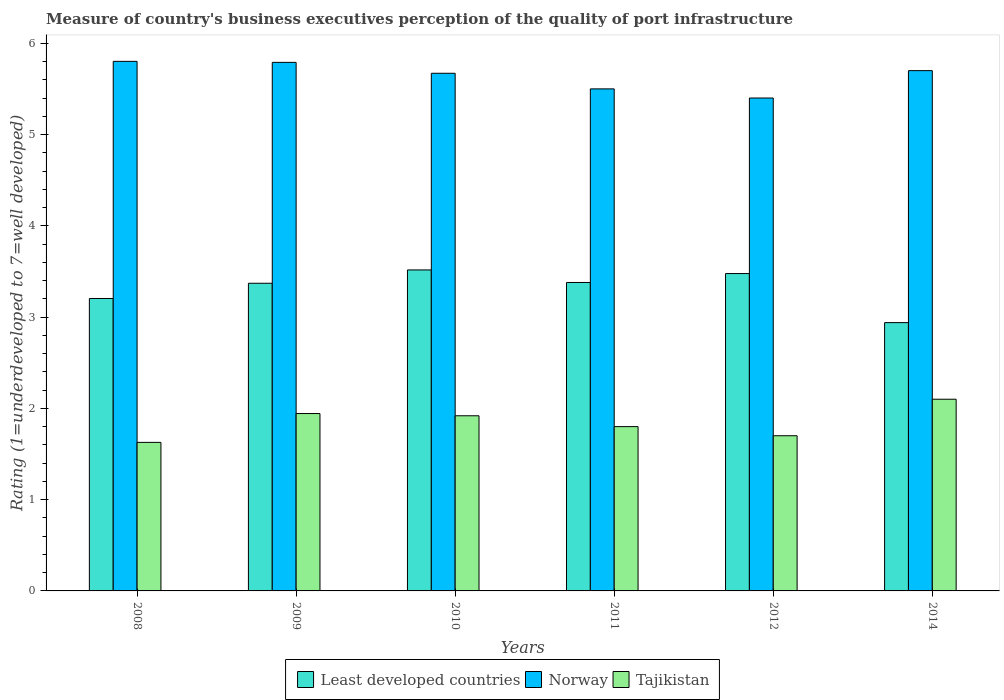Are the number of bars on each tick of the X-axis equal?
Your response must be concise. Yes. How many bars are there on the 2nd tick from the right?
Your response must be concise. 3. In how many cases, is the number of bars for a given year not equal to the number of legend labels?
Provide a succinct answer. 0. What is the ratings of the quality of port infrastructure in Least developed countries in 2010?
Provide a short and direct response. 3.52. Across all years, what is the maximum ratings of the quality of port infrastructure in Norway?
Offer a terse response. 5.8. Across all years, what is the minimum ratings of the quality of port infrastructure in Least developed countries?
Keep it short and to the point. 2.94. What is the total ratings of the quality of port infrastructure in Norway in the graph?
Offer a very short reply. 33.86. What is the difference between the ratings of the quality of port infrastructure in Least developed countries in 2008 and that in 2010?
Your answer should be compact. -0.31. What is the difference between the ratings of the quality of port infrastructure in Least developed countries in 2010 and the ratings of the quality of port infrastructure in Tajikistan in 2009?
Ensure brevity in your answer.  1.57. What is the average ratings of the quality of port infrastructure in Norway per year?
Offer a very short reply. 5.64. In the year 2012, what is the difference between the ratings of the quality of port infrastructure in Tajikistan and ratings of the quality of port infrastructure in Least developed countries?
Keep it short and to the point. -1.78. In how many years, is the ratings of the quality of port infrastructure in Norway greater than 2.4?
Make the answer very short. 6. What is the ratio of the ratings of the quality of port infrastructure in Least developed countries in 2011 to that in 2014?
Provide a short and direct response. 1.15. Is the ratings of the quality of port infrastructure in Least developed countries in 2009 less than that in 2014?
Provide a succinct answer. No. What is the difference between the highest and the second highest ratings of the quality of port infrastructure in Norway?
Offer a terse response. 0.01. What is the difference between the highest and the lowest ratings of the quality of port infrastructure in Norway?
Your answer should be compact. 0.4. What does the 2nd bar from the left in 2010 represents?
Ensure brevity in your answer.  Norway. What does the 2nd bar from the right in 2011 represents?
Provide a short and direct response. Norway. How many bars are there?
Keep it short and to the point. 18. How many years are there in the graph?
Your answer should be compact. 6. Does the graph contain any zero values?
Offer a very short reply. No. Does the graph contain grids?
Your response must be concise. No. Where does the legend appear in the graph?
Your answer should be very brief. Bottom center. How many legend labels are there?
Your answer should be compact. 3. What is the title of the graph?
Your response must be concise. Measure of country's business executives perception of the quality of port infrastructure. Does "Croatia" appear as one of the legend labels in the graph?
Offer a very short reply. No. What is the label or title of the Y-axis?
Your response must be concise. Rating (1=underdeveloped to 7=well developed). What is the Rating (1=underdeveloped to 7=well developed) in Least developed countries in 2008?
Offer a very short reply. 3.2. What is the Rating (1=underdeveloped to 7=well developed) of Norway in 2008?
Give a very brief answer. 5.8. What is the Rating (1=underdeveloped to 7=well developed) of Tajikistan in 2008?
Your response must be concise. 1.63. What is the Rating (1=underdeveloped to 7=well developed) in Least developed countries in 2009?
Give a very brief answer. 3.37. What is the Rating (1=underdeveloped to 7=well developed) of Norway in 2009?
Offer a very short reply. 5.79. What is the Rating (1=underdeveloped to 7=well developed) in Tajikistan in 2009?
Offer a very short reply. 1.94. What is the Rating (1=underdeveloped to 7=well developed) of Least developed countries in 2010?
Offer a very short reply. 3.52. What is the Rating (1=underdeveloped to 7=well developed) of Norway in 2010?
Give a very brief answer. 5.67. What is the Rating (1=underdeveloped to 7=well developed) of Tajikistan in 2010?
Offer a terse response. 1.92. What is the Rating (1=underdeveloped to 7=well developed) in Least developed countries in 2011?
Ensure brevity in your answer.  3.38. What is the Rating (1=underdeveloped to 7=well developed) in Least developed countries in 2012?
Keep it short and to the point. 3.48. What is the Rating (1=underdeveloped to 7=well developed) in Tajikistan in 2012?
Your answer should be very brief. 1.7. What is the Rating (1=underdeveloped to 7=well developed) in Least developed countries in 2014?
Your answer should be compact. 2.94. What is the Rating (1=underdeveloped to 7=well developed) of Norway in 2014?
Offer a terse response. 5.7. What is the Rating (1=underdeveloped to 7=well developed) of Tajikistan in 2014?
Offer a terse response. 2.1. Across all years, what is the maximum Rating (1=underdeveloped to 7=well developed) in Least developed countries?
Make the answer very short. 3.52. Across all years, what is the maximum Rating (1=underdeveloped to 7=well developed) in Norway?
Your answer should be very brief. 5.8. Across all years, what is the maximum Rating (1=underdeveloped to 7=well developed) of Tajikistan?
Your answer should be compact. 2.1. Across all years, what is the minimum Rating (1=underdeveloped to 7=well developed) in Least developed countries?
Provide a short and direct response. 2.94. Across all years, what is the minimum Rating (1=underdeveloped to 7=well developed) of Tajikistan?
Provide a short and direct response. 1.63. What is the total Rating (1=underdeveloped to 7=well developed) of Least developed countries in the graph?
Offer a very short reply. 19.89. What is the total Rating (1=underdeveloped to 7=well developed) of Norway in the graph?
Your response must be concise. 33.86. What is the total Rating (1=underdeveloped to 7=well developed) in Tajikistan in the graph?
Your response must be concise. 11.09. What is the difference between the Rating (1=underdeveloped to 7=well developed) in Least developed countries in 2008 and that in 2009?
Ensure brevity in your answer.  -0.17. What is the difference between the Rating (1=underdeveloped to 7=well developed) in Norway in 2008 and that in 2009?
Provide a short and direct response. 0.01. What is the difference between the Rating (1=underdeveloped to 7=well developed) of Tajikistan in 2008 and that in 2009?
Offer a terse response. -0.32. What is the difference between the Rating (1=underdeveloped to 7=well developed) of Least developed countries in 2008 and that in 2010?
Keep it short and to the point. -0.31. What is the difference between the Rating (1=underdeveloped to 7=well developed) of Norway in 2008 and that in 2010?
Keep it short and to the point. 0.13. What is the difference between the Rating (1=underdeveloped to 7=well developed) in Tajikistan in 2008 and that in 2010?
Your answer should be very brief. -0.29. What is the difference between the Rating (1=underdeveloped to 7=well developed) of Least developed countries in 2008 and that in 2011?
Your answer should be very brief. -0.18. What is the difference between the Rating (1=underdeveloped to 7=well developed) of Norway in 2008 and that in 2011?
Offer a terse response. 0.3. What is the difference between the Rating (1=underdeveloped to 7=well developed) in Tajikistan in 2008 and that in 2011?
Your response must be concise. -0.17. What is the difference between the Rating (1=underdeveloped to 7=well developed) in Least developed countries in 2008 and that in 2012?
Your response must be concise. -0.27. What is the difference between the Rating (1=underdeveloped to 7=well developed) in Norway in 2008 and that in 2012?
Your answer should be compact. 0.4. What is the difference between the Rating (1=underdeveloped to 7=well developed) of Tajikistan in 2008 and that in 2012?
Ensure brevity in your answer.  -0.07. What is the difference between the Rating (1=underdeveloped to 7=well developed) in Least developed countries in 2008 and that in 2014?
Provide a short and direct response. 0.26. What is the difference between the Rating (1=underdeveloped to 7=well developed) of Norway in 2008 and that in 2014?
Provide a short and direct response. 0.1. What is the difference between the Rating (1=underdeveloped to 7=well developed) of Tajikistan in 2008 and that in 2014?
Offer a terse response. -0.47. What is the difference between the Rating (1=underdeveloped to 7=well developed) of Least developed countries in 2009 and that in 2010?
Your answer should be very brief. -0.15. What is the difference between the Rating (1=underdeveloped to 7=well developed) of Norway in 2009 and that in 2010?
Your answer should be very brief. 0.12. What is the difference between the Rating (1=underdeveloped to 7=well developed) of Tajikistan in 2009 and that in 2010?
Provide a succinct answer. 0.02. What is the difference between the Rating (1=underdeveloped to 7=well developed) of Least developed countries in 2009 and that in 2011?
Give a very brief answer. -0.01. What is the difference between the Rating (1=underdeveloped to 7=well developed) of Norway in 2009 and that in 2011?
Your response must be concise. 0.29. What is the difference between the Rating (1=underdeveloped to 7=well developed) of Tajikistan in 2009 and that in 2011?
Make the answer very short. 0.14. What is the difference between the Rating (1=underdeveloped to 7=well developed) of Least developed countries in 2009 and that in 2012?
Offer a terse response. -0.11. What is the difference between the Rating (1=underdeveloped to 7=well developed) in Norway in 2009 and that in 2012?
Your answer should be very brief. 0.39. What is the difference between the Rating (1=underdeveloped to 7=well developed) in Tajikistan in 2009 and that in 2012?
Keep it short and to the point. 0.24. What is the difference between the Rating (1=underdeveloped to 7=well developed) in Least developed countries in 2009 and that in 2014?
Your response must be concise. 0.43. What is the difference between the Rating (1=underdeveloped to 7=well developed) in Norway in 2009 and that in 2014?
Give a very brief answer. 0.09. What is the difference between the Rating (1=underdeveloped to 7=well developed) in Tajikistan in 2009 and that in 2014?
Your response must be concise. -0.16. What is the difference between the Rating (1=underdeveloped to 7=well developed) of Least developed countries in 2010 and that in 2011?
Ensure brevity in your answer.  0.14. What is the difference between the Rating (1=underdeveloped to 7=well developed) in Norway in 2010 and that in 2011?
Offer a very short reply. 0.17. What is the difference between the Rating (1=underdeveloped to 7=well developed) of Tajikistan in 2010 and that in 2011?
Provide a succinct answer. 0.12. What is the difference between the Rating (1=underdeveloped to 7=well developed) of Least developed countries in 2010 and that in 2012?
Your answer should be compact. 0.04. What is the difference between the Rating (1=underdeveloped to 7=well developed) in Norway in 2010 and that in 2012?
Ensure brevity in your answer.  0.27. What is the difference between the Rating (1=underdeveloped to 7=well developed) in Tajikistan in 2010 and that in 2012?
Provide a short and direct response. 0.22. What is the difference between the Rating (1=underdeveloped to 7=well developed) of Least developed countries in 2010 and that in 2014?
Provide a succinct answer. 0.58. What is the difference between the Rating (1=underdeveloped to 7=well developed) of Norway in 2010 and that in 2014?
Offer a very short reply. -0.03. What is the difference between the Rating (1=underdeveloped to 7=well developed) in Tajikistan in 2010 and that in 2014?
Ensure brevity in your answer.  -0.18. What is the difference between the Rating (1=underdeveloped to 7=well developed) of Least developed countries in 2011 and that in 2012?
Provide a short and direct response. -0.1. What is the difference between the Rating (1=underdeveloped to 7=well developed) of Norway in 2011 and that in 2012?
Offer a terse response. 0.1. What is the difference between the Rating (1=underdeveloped to 7=well developed) of Tajikistan in 2011 and that in 2012?
Keep it short and to the point. 0.1. What is the difference between the Rating (1=underdeveloped to 7=well developed) of Least developed countries in 2011 and that in 2014?
Make the answer very short. 0.44. What is the difference between the Rating (1=underdeveloped to 7=well developed) of Least developed countries in 2012 and that in 2014?
Your response must be concise. 0.54. What is the difference between the Rating (1=underdeveloped to 7=well developed) in Least developed countries in 2008 and the Rating (1=underdeveloped to 7=well developed) in Norway in 2009?
Offer a terse response. -2.59. What is the difference between the Rating (1=underdeveloped to 7=well developed) of Least developed countries in 2008 and the Rating (1=underdeveloped to 7=well developed) of Tajikistan in 2009?
Give a very brief answer. 1.26. What is the difference between the Rating (1=underdeveloped to 7=well developed) in Norway in 2008 and the Rating (1=underdeveloped to 7=well developed) in Tajikistan in 2009?
Your response must be concise. 3.86. What is the difference between the Rating (1=underdeveloped to 7=well developed) in Least developed countries in 2008 and the Rating (1=underdeveloped to 7=well developed) in Norway in 2010?
Your answer should be compact. -2.47. What is the difference between the Rating (1=underdeveloped to 7=well developed) of Least developed countries in 2008 and the Rating (1=underdeveloped to 7=well developed) of Tajikistan in 2010?
Provide a succinct answer. 1.28. What is the difference between the Rating (1=underdeveloped to 7=well developed) of Norway in 2008 and the Rating (1=underdeveloped to 7=well developed) of Tajikistan in 2010?
Give a very brief answer. 3.88. What is the difference between the Rating (1=underdeveloped to 7=well developed) of Least developed countries in 2008 and the Rating (1=underdeveloped to 7=well developed) of Norway in 2011?
Give a very brief answer. -2.3. What is the difference between the Rating (1=underdeveloped to 7=well developed) in Least developed countries in 2008 and the Rating (1=underdeveloped to 7=well developed) in Tajikistan in 2011?
Keep it short and to the point. 1.4. What is the difference between the Rating (1=underdeveloped to 7=well developed) of Norway in 2008 and the Rating (1=underdeveloped to 7=well developed) of Tajikistan in 2011?
Make the answer very short. 4. What is the difference between the Rating (1=underdeveloped to 7=well developed) of Least developed countries in 2008 and the Rating (1=underdeveloped to 7=well developed) of Norway in 2012?
Offer a very short reply. -2.2. What is the difference between the Rating (1=underdeveloped to 7=well developed) in Least developed countries in 2008 and the Rating (1=underdeveloped to 7=well developed) in Tajikistan in 2012?
Provide a succinct answer. 1.5. What is the difference between the Rating (1=underdeveloped to 7=well developed) of Norway in 2008 and the Rating (1=underdeveloped to 7=well developed) of Tajikistan in 2012?
Give a very brief answer. 4.1. What is the difference between the Rating (1=underdeveloped to 7=well developed) of Least developed countries in 2008 and the Rating (1=underdeveloped to 7=well developed) of Norway in 2014?
Ensure brevity in your answer.  -2.5. What is the difference between the Rating (1=underdeveloped to 7=well developed) in Least developed countries in 2008 and the Rating (1=underdeveloped to 7=well developed) in Tajikistan in 2014?
Your answer should be compact. 1.1. What is the difference between the Rating (1=underdeveloped to 7=well developed) of Norway in 2008 and the Rating (1=underdeveloped to 7=well developed) of Tajikistan in 2014?
Your answer should be very brief. 3.7. What is the difference between the Rating (1=underdeveloped to 7=well developed) of Least developed countries in 2009 and the Rating (1=underdeveloped to 7=well developed) of Norway in 2010?
Offer a very short reply. -2.3. What is the difference between the Rating (1=underdeveloped to 7=well developed) of Least developed countries in 2009 and the Rating (1=underdeveloped to 7=well developed) of Tajikistan in 2010?
Provide a succinct answer. 1.45. What is the difference between the Rating (1=underdeveloped to 7=well developed) in Norway in 2009 and the Rating (1=underdeveloped to 7=well developed) in Tajikistan in 2010?
Ensure brevity in your answer.  3.87. What is the difference between the Rating (1=underdeveloped to 7=well developed) of Least developed countries in 2009 and the Rating (1=underdeveloped to 7=well developed) of Norway in 2011?
Provide a short and direct response. -2.13. What is the difference between the Rating (1=underdeveloped to 7=well developed) in Least developed countries in 2009 and the Rating (1=underdeveloped to 7=well developed) in Tajikistan in 2011?
Provide a short and direct response. 1.57. What is the difference between the Rating (1=underdeveloped to 7=well developed) in Norway in 2009 and the Rating (1=underdeveloped to 7=well developed) in Tajikistan in 2011?
Keep it short and to the point. 3.99. What is the difference between the Rating (1=underdeveloped to 7=well developed) in Least developed countries in 2009 and the Rating (1=underdeveloped to 7=well developed) in Norway in 2012?
Keep it short and to the point. -2.03. What is the difference between the Rating (1=underdeveloped to 7=well developed) of Least developed countries in 2009 and the Rating (1=underdeveloped to 7=well developed) of Tajikistan in 2012?
Your answer should be very brief. 1.67. What is the difference between the Rating (1=underdeveloped to 7=well developed) of Norway in 2009 and the Rating (1=underdeveloped to 7=well developed) of Tajikistan in 2012?
Keep it short and to the point. 4.09. What is the difference between the Rating (1=underdeveloped to 7=well developed) in Least developed countries in 2009 and the Rating (1=underdeveloped to 7=well developed) in Norway in 2014?
Your response must be concise. -2.33. What is the difference between the Rating (1=underdeveloped to 7=well developed) of Least developed countries in 2009 and the Rating (1=underdeveloped to 7=well developed) of Tajikistan in 2014?
Ensure brevity in your answer.  1.27. What is the difference between the Rating (1=underdeveloped to 7=well developed) of Norway in 2009 and the Rating (1=underdeveloped to 7=well developed) of Tajikistan in 2014?
Make the answer very short. 3.69. What is the difference between the Rating (1=underdeveloped to 7=well developed) of Least developed countries in 2010 and the Rating (1=underdeveloped to 7=well developed) of Norway in 2011?
Your answer should be compact. -1.98. What is the difference between the Rating (1=underdeveloped to 7=well developed) of Least developed countries in 2010 and the Rating (1=underdeveloped to 7=well developed) of Tajikistan in 2011?
Offer a very short reply. 1.72. What is the difference between the Rating (1=underdeveloped to 7=well developed) of Norway in 2010 and the Rating (1=underdeveloped to 7=well developed) of Tajikistan in 2011?
Your answer should be very brief. 3.87. What is the difference between the Rating (1=underdeveloped to 7=well developed) in Least developed countries in 2010 and the Rating (1=underdeveloped to 7=well developed) in Norway in 2012?
Make the answer very short. -1.88. What is the difference between the Rating (1=underdeveloped to 7=well developed) of Least developed countries in 2010 and the Rating (1=underdeveloped to 7=well developed) of Tajikistan in 2012?
Your answer should be compact. 1.82. What is the difference between the Rating (1=underdeveloped to 7=well developed) in Norway in 2010 and the Rating (1=underdeveloped to 7=well developed) in Tajikistan in 2012?
Keep it short and to the point. 3.97. What is the difference between the Rating (1=underdeveloped to 7=well developed) of Least developed countries in 2010 and the Rating (1=underdeveloped to 7=well developed) of Norway in 2014?
Offer a very short reply. -2.18. What is the difference between the Rating (1=underdeveloped to 7=well developed) of Least developed countries in 2010 and the Rating (1=underdeveloped to 7=well developed) of Tajikistan in 2014?
Your answer should be compact. 1.42. What is the difference between the Rating (1=underdeveloped to 7=well developed) of Norway in 2010 and the Rating (1=underdeveloped to 7=well developed) of Tajikistan in 2014?
Your response must be concise. 3.57. What is the difference between the Rating (1=underdeveloped to 7=well developed) in Least developed countries in 2011 and the Rating (1=underdeveloped to 7=well developed) in Norway in 2012?
Your answer should be compact. -2.02. What is the difference between the Rating (1=underdeveloped to 7=well developed) of Least developed countries in 2011 and the Rating (1=underdeveloped to 7=well developed) of Tajikistan in 2012?
Your answer should be compact. 1.68. What is the difference between the Rating (1=underdeveloped to 7=well developed) in Norway in 2011 and the Rating (1=underdeveloped to 7=well developed) in Tajikistan in 2012?
Keep it short and to the point. 3.8. What is the difference between the Rating (1=underdeveloped to 7=well developed) of Least developed countries in 2011 and the Rating (1=underdeveloped to 7=well developed) of Norway in 2014?
Your response must be concise. -2.32. What is the difference between the Rating (1=underdeveloped to 7=well developed) of Least developed countries in 2011 and the Rating (1=underdeveloped to 7=well developed) of Tajikistan in 2014?
Your response must be concise. 1.28. What is the difference between the Rating (1=underdeveloped to 7=well developed) of Least developed countries in 2012 and the Rating (1=underdeveloped to 7=well developed) of Norway in 2014?
Offer a very short reply. -2.22. What is the difference between the Rating (1=underdeveloped to 7=well developed) of Least developed countries in 2012 and the Rating (1=underdeveloped to 7=well developed) of Tajikistan in 2014?
Your answer should be compact. 1.38. What is the difference between the Rating (1=underdeveloped to 7=well developed) in Norway in 2012 and the Rating (1=underdeveloped to 7=well developed) in Tajikistan in 2014?
Ensure brevity in your answer.  3.3. What is the average Rating (1=underdeveloped to 7=well developed) of Least developed countries per year?
Offer a terse response. 3.31. What is the average Rating (1=underdeveloped to 7=well developed) in Norway per year?
Make the answer very short. 5.64. What is the average Rating (1=underdeveloped to 7=well developed) in Tajikistan per year?
Make the answer very short. 1.85. In the year 2008, what is the difference between the Rating (1=underdeveloped to 7=well developed) of Least developed countries and Rating (1=underdeveloped to 7=well developed) of Norway?
Keep it short and to the point. -2.6. In the year 2008, what is the difference between the Rating (1=underdeveloped to 7=well developed) in Least developed countries and Rating (1=underdeveloped to 7=well developed) in Tajikistan?
Your answer should be compact. 1.58. In the year 2008, what is the difference between the Rating (1=underdeveloped to 7=well developed) of Norway and Rating (1=underdeveloped to 7=well developed) of Tajikistan?
Your answer should be compact. 4.17. In the year 2009, what is the difference between the Rating (1=underdeveloped to 7=well developed) in Least developed countries and Rating (1=underdeveloped to 7=well developed) in Norway?
Provide a short and direct response. -2.42. In the year 2009, what is the difference between the Rating (1=underdeveloped to 7=well developed) in Least developed countries and Rating (1=underdeveloped to 7=well developed) in Tajikistan?
Offer a very short reply. 1.43. In the year 2009, what is the difference between the Rating (1=underdeveloped to 7=well developed) of Norway and Rating (1=underdeveloped to 7=well developed) of Tajikistan?
Provide a succinct answer. 3.85. In the year 2010, what is the difference between the Rating (1=underdeveloped to 7=well developed) of Least developed countries and Rating (1=underdeveloped to 7=well developed) of Norway?
Make the answer very short. -2.15. In the year 2010, what is the difference between the Rating (1=underdeveloped to 7=well developed) of Least developed countries and Rating (1=underdeveloped to 7=well developed) of Tajikistan?
Ensure brevity in your answer.  1.6. In the year 2010, what is the difference between the Rating (1=underdeveloped to 7=well developed) of Norway and Rating (1=underdeveloped to 7=well developed) of Tajikistan?
Provide a succinct answer. 3.75. In the year 2011, what is the difference between the Rating (1=underdeveloped to 7=well developed) of Least developed countries and Rating (1=underdeveloped to 7=well developed) of Norway?
Keep it short and to the point. -2.12. In the year 2011, what is the difference between the Rating (1=underdeveloped to 7=well developed) of Least developed countries and Rating (1=underdeveloped to 7=well developed) of Tajikistan?
Offer a very short reply. 1.58. In the year 2011, what is the difference between the Rating (1=underdeveloped to 7=well developed) in Norway and Rating (1=underdeveloped to 7=well developed) in Tajikistan?
Ensure brevity in your answer.  3.7. In the year 2012, what is the difference between the Rating (1=underdeveloped to 7=well developed) of Least developed countries and Rating (1=underdeveloped to 7=well developed) of Norway?
Offer a very short reply. -1.92. In the year 2012, what is the difference between the Rating (1=underdeveloped to 7=well developed) of Least developed countries and Rating (1=underdeveloped to 7=well developed) of Tajikistan?
Provide a short and direct response. 1.78. In the year 2012, what is the difference between the Rating (1=underdeveloped to 7=well developed) in Norway and Rating (1=underdeveloped to 7=well developed) in Tajikistan?
Make the answer very short. 3.7. In the year 2014, what is the difference between the Rating (1=underdeveloped to 7=well developed) of Least developed countries and Rating (1=underdeveloped to 7=well developed) of Norway?
Provide a succinct answer. -2.76. In the year 2014, what is the difference between the Rating (1=underdeveloped to 7=well developed) of Least developed countries and Rating (1=underdeveloped to 7=well developed) of Tajikistan?
Your answer should be compact. 0.84. In the year 2014, what is the difference between the Rating (1=underdeveloped to 7=well developed) in Norway and Rating (1=underdeveloped to 7=well developed) in Tajikistan?
Ensure brevity in your answer.  3.6. What is the ratio of the Rating (1=underdeveloped to 7=well developed) in Least developed countries in 2008 to that in 2009?
Ensure brevity in your answer.  0.95. What is the ratio of the Rating (1=underdeveloped to 7=well developed) of Tajikistan in 2008 to that in 2009?
Keep it short and to the point. 0.84. What is the ratio of the Rating (1=underdeveloped to 7=well developed) in Least developed countries in 2008 to that in 2010?
Offer a very short reply. 0.91. What is the ratio of the Rating (1=underdeveloped to 7=well developed) of Norway in 2008 to that in 2010?
Provide a succinct answer. 1.02. What is the ratio of the Rating (1=underdeveloped to 7=well developed) in Tajikistan in 2008 to that in 2010?
Your answer should be compact. 0.85. What is the ratio of the Rating (1=underdeveloped to 7=well developed) in Least developed countries in 2008 to that in 2011?
Provide a short and direct response. 0.95. What is the ratio of the Rating (1=underdeveloped to 7=well developed) of Norway in 2008 to that in 2011?
Provide a succinct answer. 1.05. What is the ratio of the Rating (1=underdeveloped to 7=well developed) in Tajikistan in 2008 to that in 2011?
Give a very brief answer. 0.9. What is the ratio of the Rating (1=underdeveloped to 7=well developed) of Least developed countries in 2008 to that in 2012?
Make the answer very short. 0.92. What is the ratio of the Rating (1=underdeveloped to 7=well developed) of Norway in 2008 to that in 2012?
Provide a short and direct response. 1.07. What is the ratio of the Rating (1=underdeveloped to 7=well developed) of Tajikistan in 2008 to that in 2012?
Keep it short and to the point. 0.96. What is the ratio of the Rating (1=underdeveloped to 7=well developed) in Least developed countries in 2008 to that in 2014?
Provide a short and direct response. 1.09. What is the ratio of the Rating (1=underdeveloped to 7=well developed) in Norway in 2008 to that in 2014?
Provide a succinct answer. 1.02. What is the ratio of the Rating (1=underdeveloped to 7=well developed) in Tajikistan in 2008 to that in 2014?
Give a very brief answer. 0.77. What is the ratio of the Rating (1=underdeveloped to 7=well developed) of Least developed countries in 2009 to that in 2010?
Your answer should be very brief. 0.96. What is the ratio of the Rating (1=underdeveloped to 7=well developed) in Tajikistan in 2009 to that in 2010?
Your answer should be compact. 1.01. What is the ratio of the Rating (1=underdeveloped to 7=well developed) in Norway in 2009 to that in 2011?
Provide a short and direct response. 1.05. What is the ratio of the Rating (1=underdeveloped to 7=well developed) of Tajikistan in 2009 to that in 2011?
Give a very brief answer. 1.08. What is the ratio of the Rating (1=underdeveloped to 7=well developed) in Least developed countries in 2009 to that in 2012?
Offer a very short reply. 0.97. What is the ratio of the Rating (1=underdeveloped to 7=well developed) of Norway in 2009 to that in 2012?
Provide a short and direct response. 1.07. What is the ratio of the Rating (1=underdeveloped to 7=well developed) of Tajikistan in 2009 to that in 2012?
Keep it short and to the point. 1.14. What is the ratio of the Rating (1=underdeveloped to 7=well developed) of Least developed countries in 2009 to that in 2014?
Offer a very short reply. 1.15. What is the ratio of the Rating (1=underdeveloped to 7=well developed) of Norway in 2009 to that in 2014?
Offer a terse response. 1.02. What is the ratio of the Rating (1=underdeveloped to 7=well developed) in Tajikistan in 2009 to that in 2014?
Provide a succinct answer. 0.93. What is the ratio of the Rating (1=underdeveloped to 7=well developed) of Least developed countries in 2010 to that in 2011?
Offer a very short reply. 1.04. What is the ratio of the Rating (1=underdeveloped to 7=well developed) in Norway in 2010 to that in 2011?
Ensure brevity in your answer.  1.03. What is the ratio of the Rating (1=underdeveloped to 7=well developed) of Tajikistan in 2010 to that in 2011?
Make the answer very short. 1.07. What is the ratio of the Rating (1=underdeveloped to 7=well developed) in Least developed countries in 2010 to that in 2012?
Your answer should be compact. 1.01. What is the ratio of the Rating (1=underdeveloped to 7=well developed) in Norway in 2010 to that in 2012?
Your response must be concise. 1.05. What is the ratio of the Rating (1=underdeveloped to 7=well developed) in Tajikistan in 2010 to that in 2012?
Ensure brevity in your answer.  1.13. What is the ratio of the Rating (1=underdeveloped to 7=well developed) of Least developed countries in 2010 to that in 2014?
Your answer should be compact. 1.2. What is the ratio of the Rating (1=underdeveloped to 7=well developed) in Norway in 2010 to that in 2014?
Your response must be concise. 0.99. What is the ratio of the Rating (1=underdeveloped to 7=well developed) of Tajikistan in 2010 to that in 2014?
Give a very brief answer. 0.91. What is the ratio of the Rating (1=underdeveloped to 7=well developed) of Least developed countries in 2011 to that in 2012?
Provide a short and direct response. 0.97. What is the ratio of the Rating (1=underdeveloped to 7=well developed) of Norway in 2011 to that in 2012?
Keep it short and to the point. 1.02. What is the ratio of the Rating (1=underdeveloped to 7=well developed) of Tajikistan in 2011 to that in 2012?
Give a very brief answer. 1.06. What is the ratio of the Rating (1=underdeveloped to 7=well developed) in Least developed countries in 2011 to that in 2014?
Offer a terse response. 1.15. What is the ratio of the Rating (1=underdeveloped to 7=well developed) in Norway in 2011 to that in 2014?
Offer a terse response. 0.96. What is the ratio of the Rating (1=underdeveloped to 7=well developed) in Tajikistan in 2011 to that in 2014?
Ensure brevity in your answer.  0.86. What is the ratio of the Rating (1=underdeveloped to 7=well developed) in Least developed countries in 2012 to that in 2014?
Your answer should be compact. 1.18. What is the ratio of the Rating (1=underdeveloped to 7=well developed) in Norway in 2012 to that in 2014?
Offer a very short reply. 0.95. What is the ratio of the Rating (1=underdeveloped to 7=well developed) of Tajikistan in 2012 to that in 2014?
Provide a succinct answer. 0.81. What is the difference between the highest and the second highest Rating (1=underdeveloped to 7=well developed) of Least developed countries?
Ensure brevity in your answer.  0.04. What is the difference between the highest and the second highest Rating (1=underdeveloped to 7=well developed) in Norway?
Your response must be concise. 0.01. What is the difference between the highest and the second highest Rating (1=underdeveloped to 7=well developed) in Tajikistan?
Your answer should be very brief. 0.16. What is the difference between the highest and the lowest Rating (1=underdeveloped to 7=well developed) in Least developed countries?
Your answer should be compact. 0.58. What is the difference between the highest and the lowest Rating (1=underdeveloped to 7=well developed) in Norway?
Provide a succinct answer. 0.4. What is the difference between the highest and the lowest Rating (1=underdeveloped to 7=well developed) in Tajikistan?
Your answer should be very brief. 0.47. 